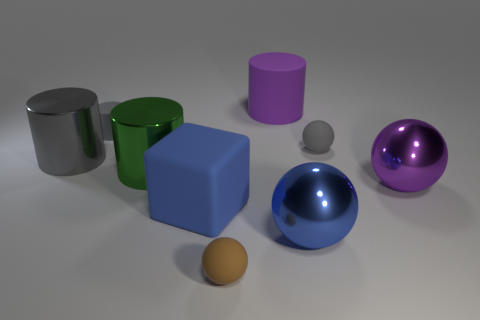What is the size of the rubber object that is the same color as the tiny rubber cylinder?
Your response must be concise. Small. There is a object that is the same color as the big rubber block; what is its shape?
Your response must be concise. Sphere. Is the shape of the large matte thing that is behind the large gray object the same as the tiny gray object that is on the left side of the big blue ball?
Make the answer very short. Yes. What number of large brown spheres are there?
Make the answer very short. 0. The blue object that is the same material as the tiny brown thing is what shape?
Keep it short and to the point. Cube. There is a cube; does it have the same color as the cylinder that is right of the small brown thing?
Make the answer very short. No. Is the number of purple cylinders that are in front of the large blue ball less than the number of yellow metallic things?
Ensure brevity in your answer.  No. What material is the large cylinder that is on the right side of the brown thing?
Ensure brevity in your answer.  Rubber. What number of other things are the same size as the blue matte cube?
Offer a very short reply. 5. There is a block; is its size the same as the metal thing that is in front of the large purple ball?
Make the answer very short. Yes. 